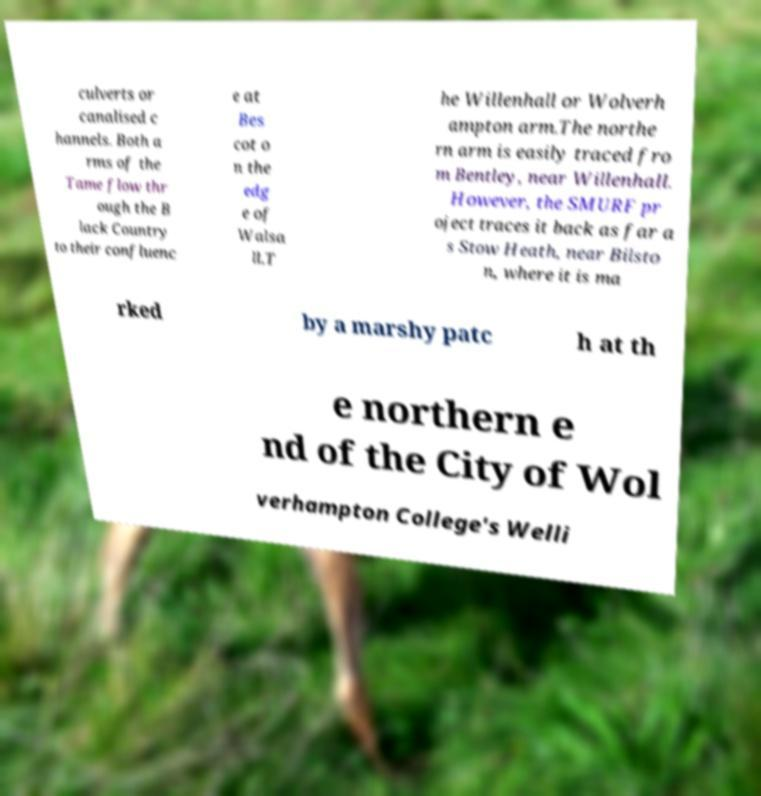Please read and relay the text visible in this image. What does it say? culverts or canalised c hannels. Both a rms of the Tame flow thr ough the B lack Country to their confluenc e at Bes cot o n the edg e of Walsa ll.T he Willenhall or Wolverh ampton arm.The northe rn arm is easily traced fro m Bentley, near Willenhall. However, the SMURF pr oject traces it back as far a s Stow Heath, near Bilsto n, where it is ma rked by a marshy patc h at th e northern e nd of the City of Wol verhampton College's Welli 